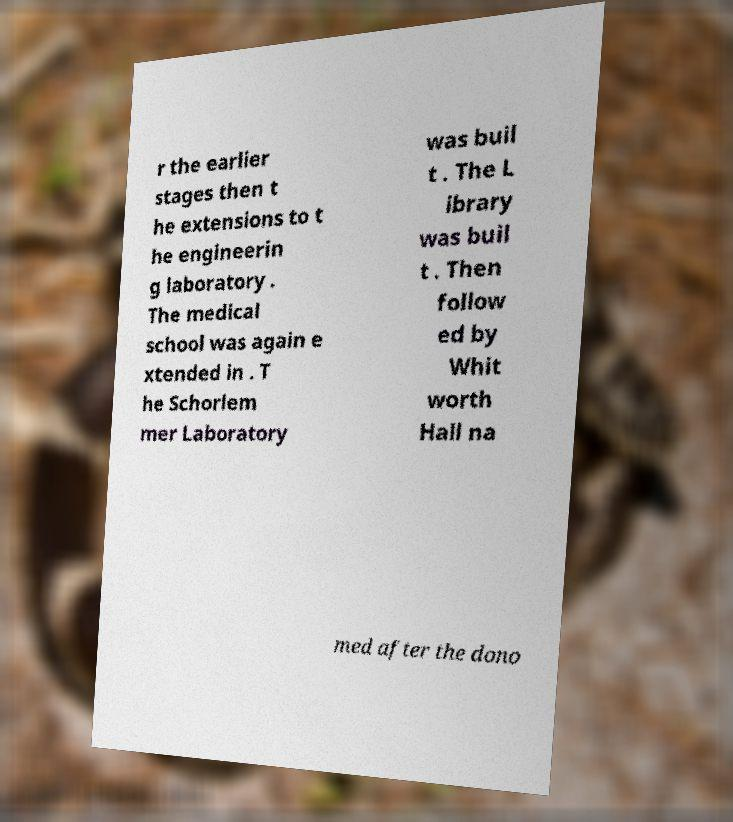For documentation purposes, I need the text within this image transcribed. Could you provide that? r the earlier stages then t he extensions to t he engineerin g laboratory . The medical school was again e xtended in . T he Schorlem mer Laboratory was buil t . The L ibrary was buil t . Then follow ed by Whit worth Hall na med after the dono 